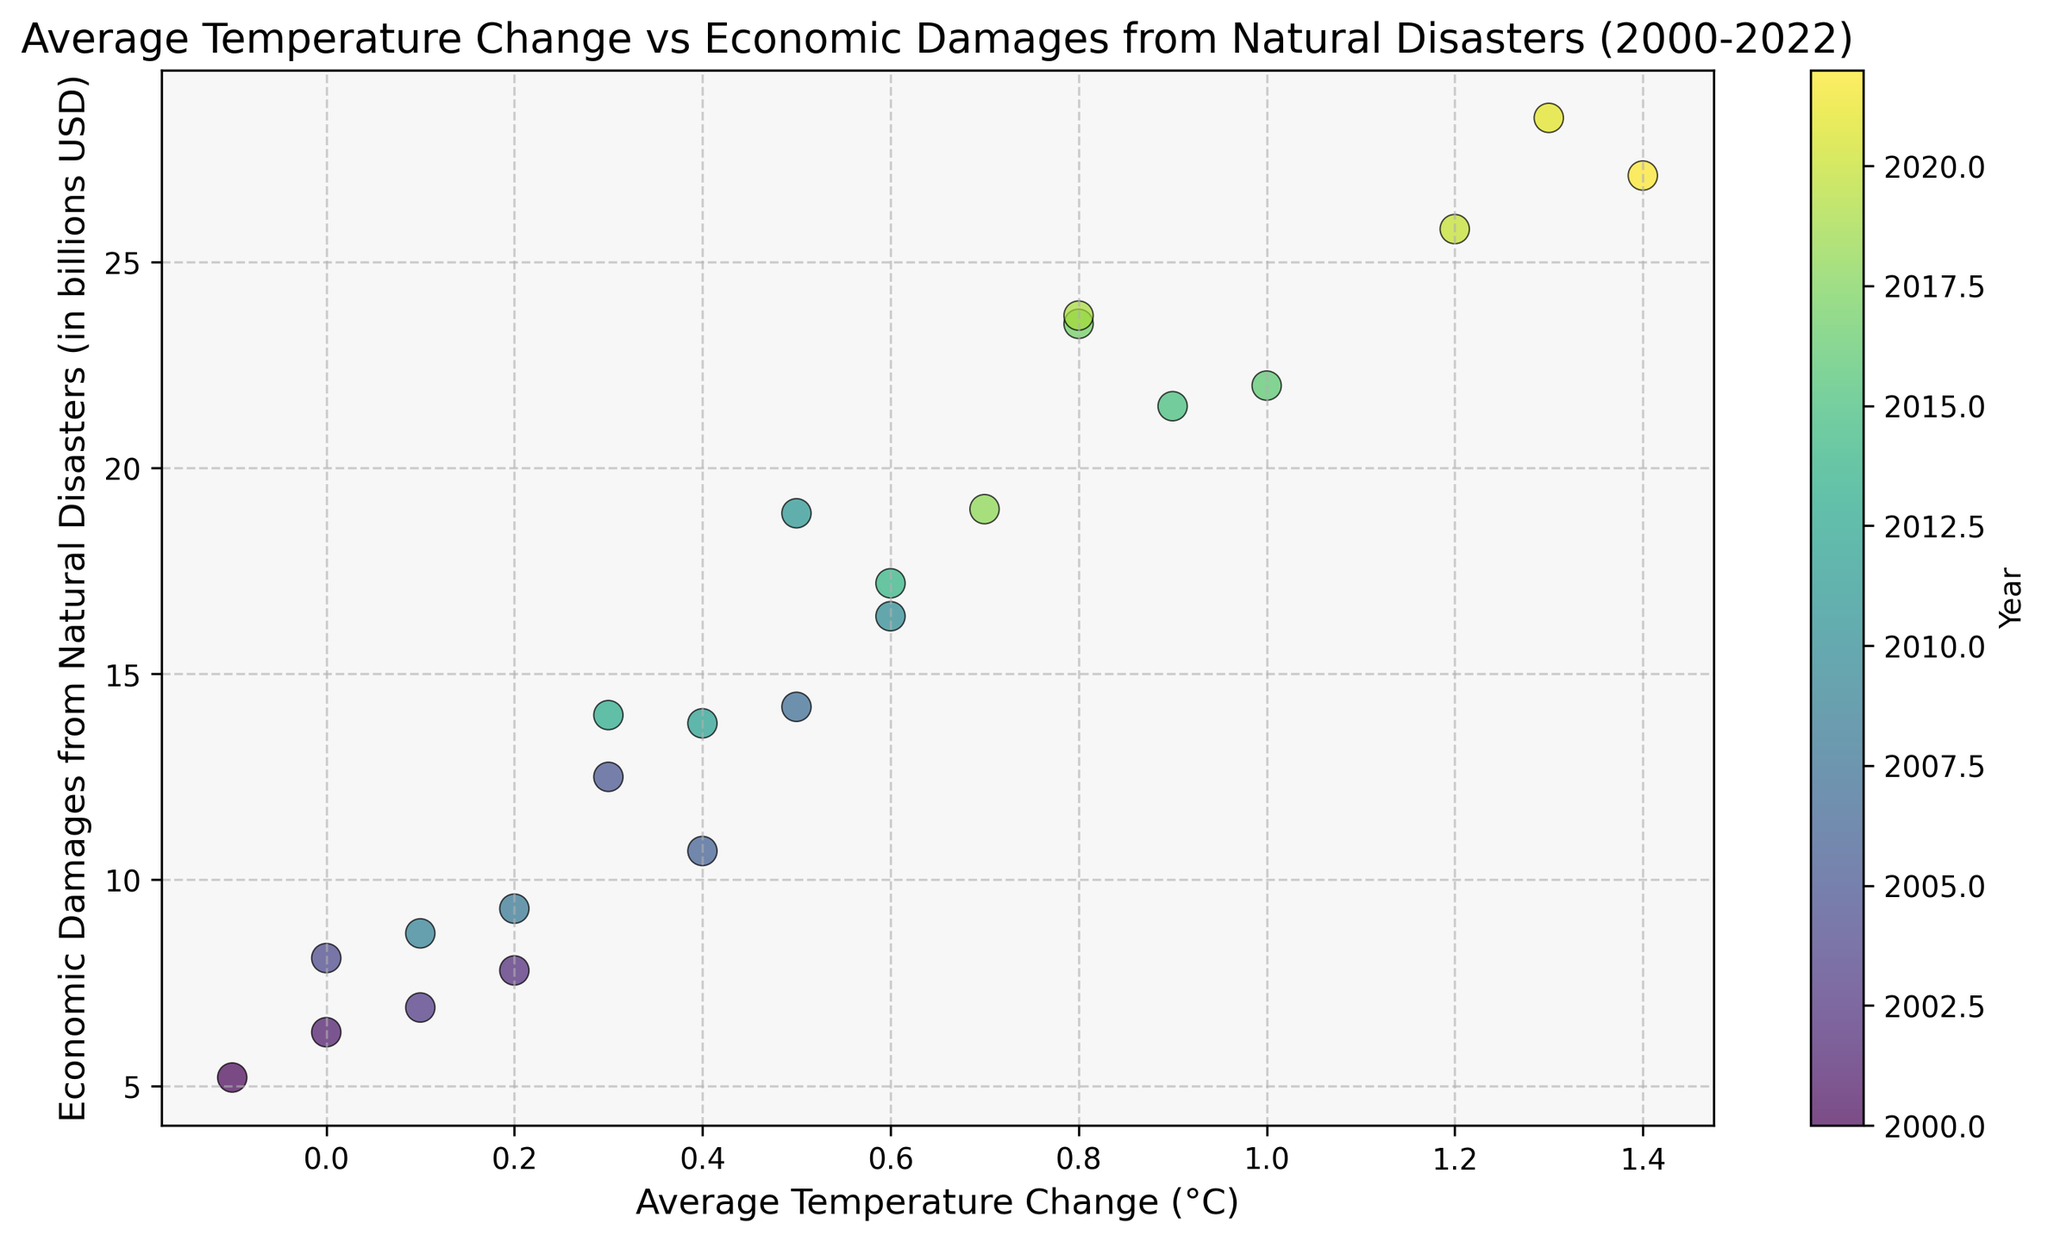What is the overall trend between average temperature change and economic damages from natural disasters? As the average temperature change increases, the economic damages from natural disasters also tend to increase. This can be observed from the upward trend in the scatter plot, where higher temperature changes correspond to higher economic damages.
Answer: Upward trend Which year had the highest economic damages and what was the average temperature change in that year? The year with the highest economic damages is seen at the highest point on the y-axis, which is 2021 with $28.5 billion in damages. The average temperature change in that year was 1.3°C, as indicated by the color and the x-axis position.
Answer: 2021, 1.3°C What is the range of average temperature change in the data? The lowest average temperature change is -0.1°C and the highest is 1.4°C. These values can be deduced by looking at the minimum and maximum points on the x-axis of the scatter plot.
Answer: -0.1°C to 1.4°C How many years had an average temperature change of 0.6°C and above? By counting the data points on the scatter plot from an x-axis value of 0.6°C and higher, there are data points for the years 2010, 2014, 2015, 2016, 2017, 2018, 2019, 2020, 2021, and 2022. This totals 10 years.
Answer: 10 years Which year had the lowest economic damages and what was the average temperature change in that year? The year with the lowest economic damages is seen at the lowest point on the y-axis, which is 2000 with $5.2 billion in damages. The average temperature change in that year was -0.1°C.
Answer: 2000, -0.1°C Compare the economic damages from natural disasters in the year 2005 with 2010. Which year had higher damages and by how much? From the scatter plot, 2005 had $12.5 billion in damages and 2010 had $16.4 billion in damages. 2010 had higher damages by $(16.4 - 12.5) = $3.9 billion.
Answer: 2010 by $3.9 billion What's the economic damage difference between the year with the highest temperature change and the year with the lowest temperature change? The highest temperature change was 1.4°C in 2022 with $27.1 billion in damages. The lowest temperature change was -0.1°C in 2000 with $5.2 billion in damages. The difference in economic damages is $(27.1 - 5.2) = $21.9 billion.
Answer: $21.9 billion Identify the time period with a consistently low average temperature change and low economic damages. The period from 2000 to 2004 shows relatively low average temperature changes ranging from -0.1°C to 0.0°C and economic damages from $5.2 billion to $8.1 billion, as seen from the clustered lower left points in the scatter plot.
Answer: 2000 to 2004 What is the median temperature change value in the scatter plot data? To find the median, list the temperature values in ascending order: -0.1, 0.0, 0.0, 0.0, 0.1, 0.1, 0.2, 0.2, 0.3, 0.3, 0.4, 0.4, 0.5, 0.5, 0.6, 0.6, 0.7, 0.8, 0.8, 0.9, 1.0, 1.2, 1.3, 1.4. The middle value is 0.4. For 23 values, the 12th value in the ordered list is the median.
Answer: 0.4°C 